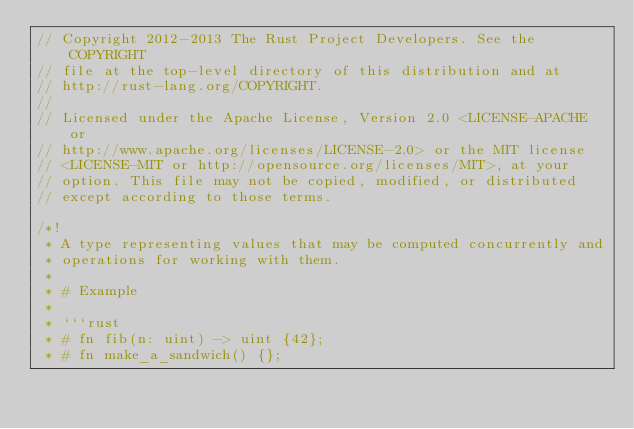Convert code to text. <code><loc_0><loc_0><loc_500><loc_500><_Rust_>// Copyright 2012-2013 The Rust Project Developers. See the COPYRIGHT
// file at the top-level directory of this distribution and at
// http://rust-lang.org/COPYRIGHT.
//
// Licensed under the Apache License, Version 2.0 <LICENSE-APACHE or
// http://www.apache.org/licenses/LICENSE-2.0> or the MIT license
// <LICENSE-MIT or http://opensource.org/licenses/MIT>, at your
// option. This file may not be copied, modified, or distributed
// except according to those terms.

/*!
 * A type representing values that may be computed concurrently and
 * operations for working with them.
 *
 * # Example
 *
 * ```rust
 * # fn fib(n: uint) -> uint {42};
 * # fn make_a_sandwich() {};</code> 